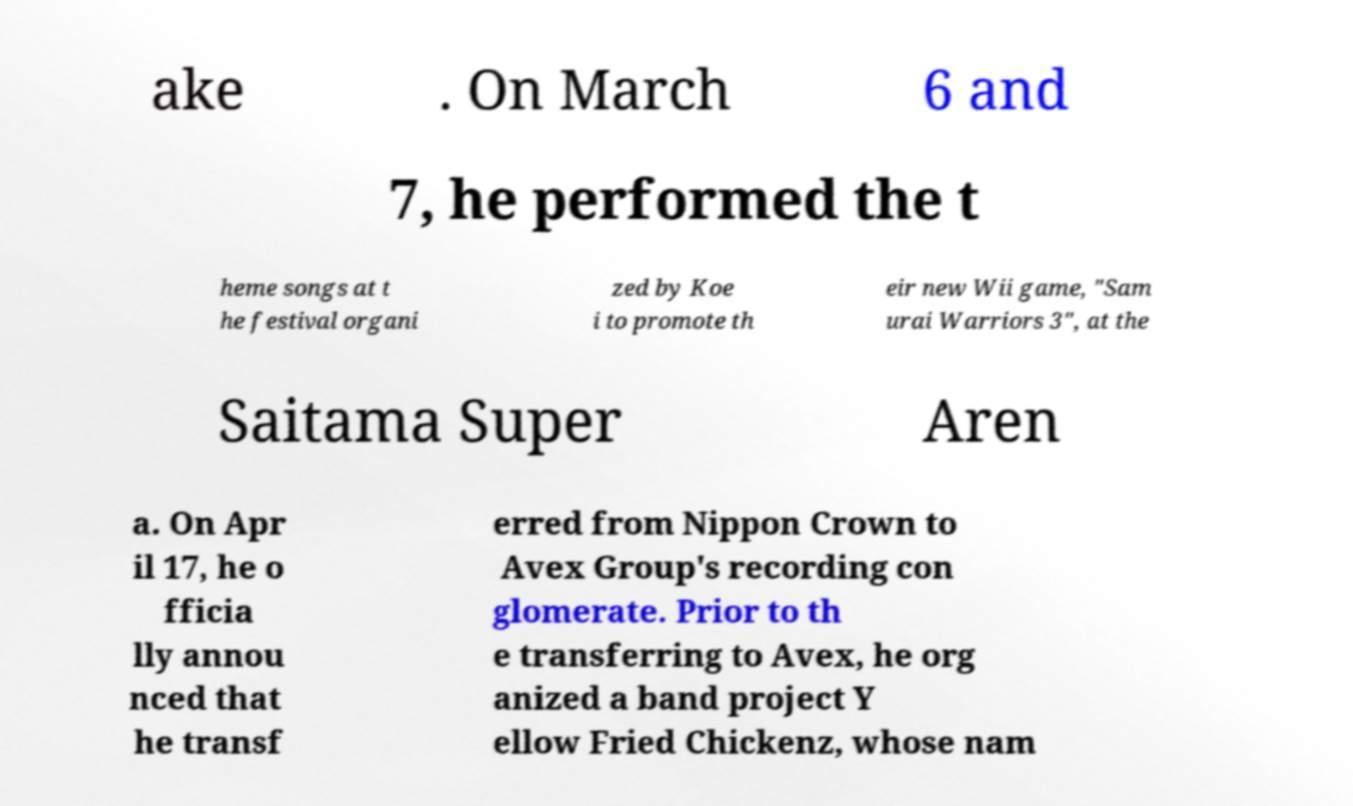What messages or text are displayed in this image? I need them in a readable, typed format. ake . On March 6 and 7, he performed the t heme songs at t he festival organi zed by Koe i to promote th eir new Wii game, "Sam urai Warriors 3", at the Saitama Super Aren a. On Apr il 17, he o fficia lly annou nced that he transf erred from Nippon Crown to Avex Group's recording con glomerate. Prior to th e transferring to Avex, he org anized a band project Y ellow Fried Chickenz, whose nam 